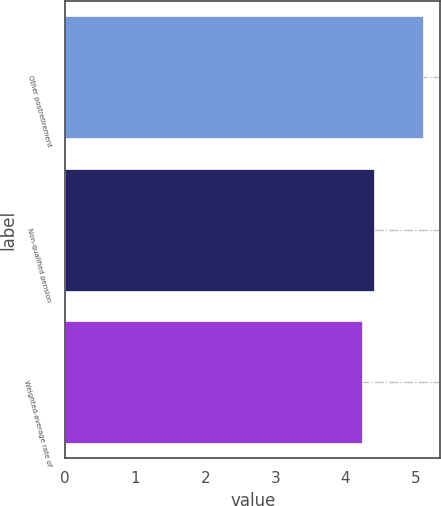<chart> <loc_0><loc_0><loc_500><loc_500><bar_chart><fcel>Other postretirement<fcel>Non-qualified pension<fcel>Weighted-average rate of<nl><fcel>5.1<fcel>4.4<fcel>4.23<nl></chart> 